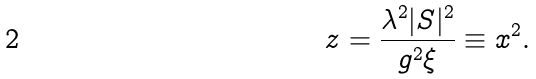Convert formula to latex. <formula><loc_0><loc_0><loc_500><loc_500>z = \frac { \lambda ^ { 2 } | S | ^ { 2 } } { g ^ { 2 } \xi } \equiv x ^ { 2 } .</formula> 